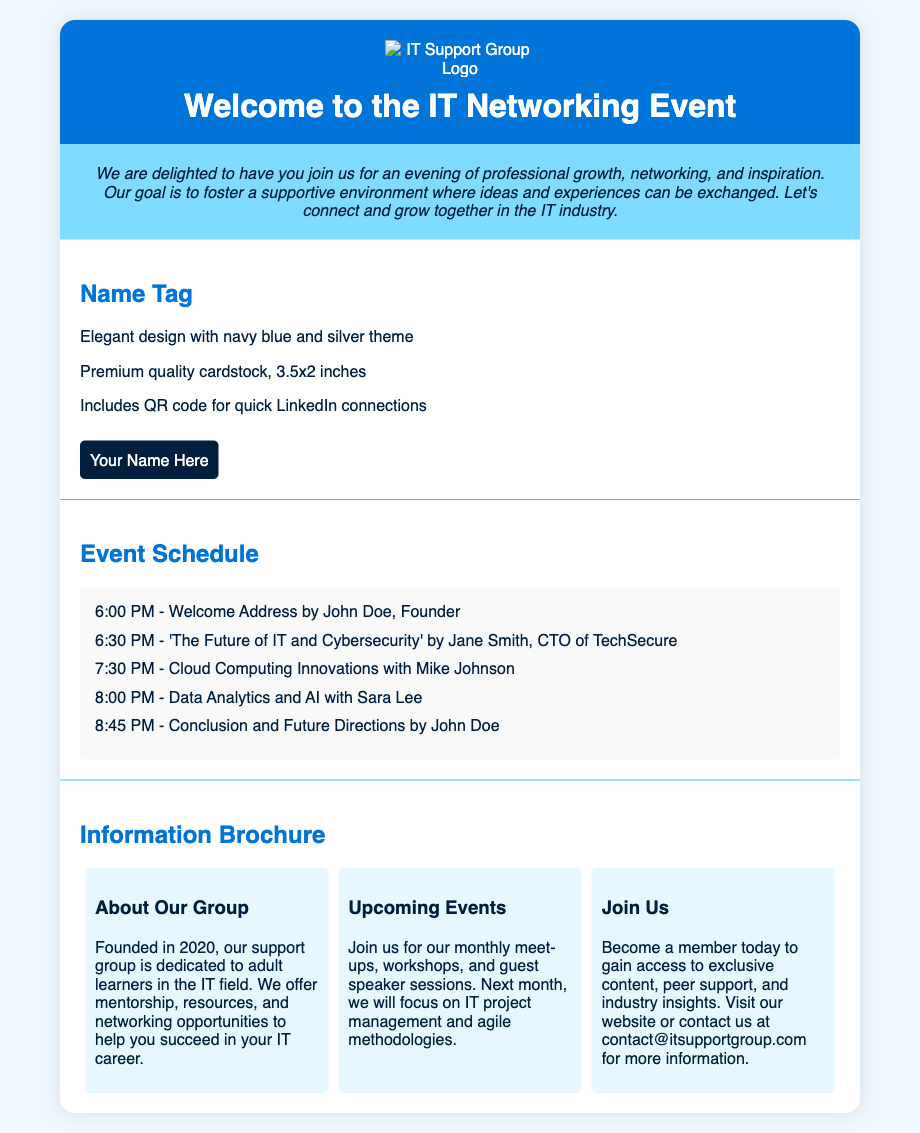What is included in the welcome package? The welcome package includes name tags, schedules, and informational brochures.
Answer: Name tags, schedules, and informational brochures What is the time for the Welcome Address? The Welcome Address is scheduled to start at 6:00 PM.
Answer: 6:00 PM Who is the speaker for the session on 'The Future of IT and Cybersecurity'? The speaker for this session is Jane Smith, CTO of TechSecure.
Answer: Jane Smith What is the theme color for the name tags? The name tags are designed with a navy blue and silver theme.
Answer: Navy blue and silver What year was the support group founded? The support group was founded in 2020.
Answer: 2020 How long is the session on Cloud Computing Innovations? The session on Cloud Computing Innovations starts at 7:30 PM and ends at 8:00 PM, making it 30 minutes long.
Answer: 30 minutes What is the main purpose of the event according to the introduction? The main purpose is to foster a supportive environment for professional growth and networking.
Answer: Professional growth and networking What type of design elements are enhanced in the event materials? The design elements reflect the theme of professional growth and peer connection.
Answer: Professional growth and peer connection What are the upcoming events focused on next month? Next month's focus is on IT project management and agile methodologies.
Answer: IT project management and agile methodologies 